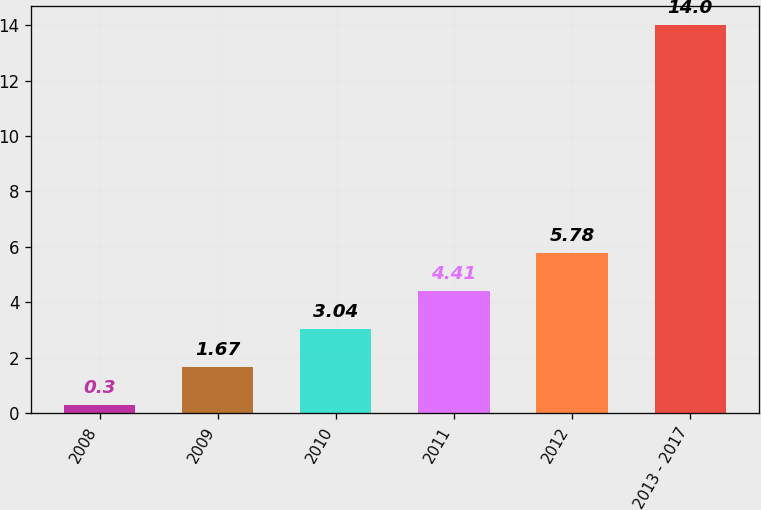<chart> <loc_0><loc_0><loc_500><loc_500><bar_chart><fcel>2008<fcel>2009<fcel>2010<fcel>2011<fcel>2012<fcel>2013 - 2017<nl><fcel>0.3<fcel>1.67<fcel>3.04<fcel>4.41<fcel>5.78<fcel>14<nl></chart> 